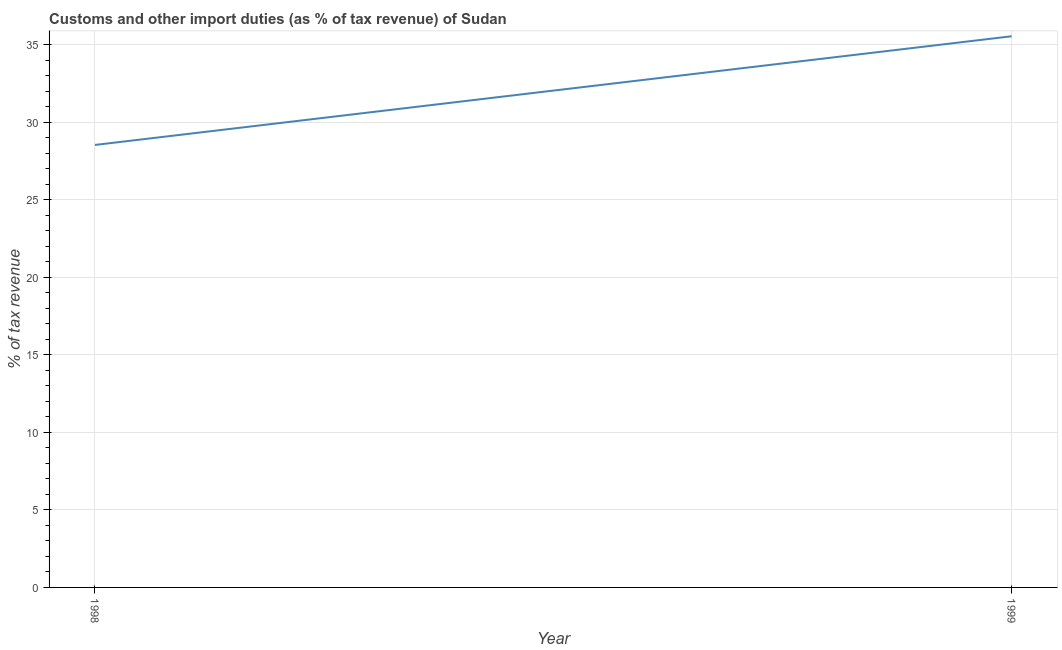What is the customs and other import duties in 1998?
Offer a terse response. 28.53. Across all years, what is the maximum customs and other import duties?
Ensure brevity in your answer.  35.54. Across all years, what is the minimum customs and other import duties?
Make the answer very short. 28.53. In which year was the customs and other import duties maximum?
Keep it short and to the point. 1999. In which year was the customs and other import duties minimum?
Your response must be concise. 1998. What is the sum of the customs and other import duties?
Make the answer very short. 64.08. What is the difference between the customs and other import duties in 1998 and 1999?
Provide a succinct answer. -7.01. What is the average customs and other import duties per year?
Make the answer very short. 32.04. What is the median customs and other import duties?
Make the answer very short. 32.04. Do a majority of the years between 1998 and 1999 (inclusive) have customs and other import duties greater than 4 %?
Ensure brevity in your answer.  Yes. What is the ratio of the customs and other import duties in 1998 to that in 1999?
Keep it short and to the point. 0.8. Is the customs and other import duties in 1998 less than that in 1999?
Keep it short and to the point. Yes. In how many years, is the customs and other import duties greater than the average customs and other import duties taken over all years?
Provide a short and direct response. 1. Does the customs and other import duties monotonically increase over the years?
Your response must be concise. Yes. How many years are there in the graph?
Provide a succinct answer. 2. Are the values on the major ticks of Y-axis written in scientific E-notation?
Offer a very short reply. No. Does the graph contain any zero values?
Your answer should be compact. No. Does the graph contain grids?
Provide a succinct answer. Yes. What is the title of the graph?
Keep it short and to the point. Customs and other import duties (as % of tax revenue) of Sudan. What is the label or title of the X-axis?
Ensure brevity in your answer.  Year. What is the label or title of the Y-axis?
Ensure brevity in your answer.  % of tax revenue. What is the % of tax revenue in 1998?
Make the answer very short. 28.53. What is the % of tax revenue in 1999?
Keep it short and to the point. 35.54. What is the difference between the % of tax revenue in 1998 and 1999?
Offer a terse response. -7.01. What is the ratio of the % of tax revenue in 1998 to that in 1999?
Your answer should be very brief. 0.8. 